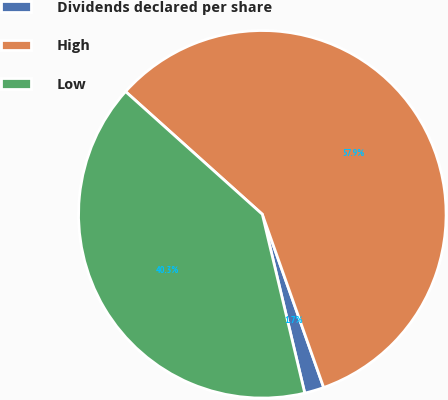Convert chart to OTSL. <chart><loc_0><loc_0><loc_500><loc_500><pie_chart><fcel>Dividends declared per share<fcel>High<fcel>Low<nl><fcel>1.71%<fcel>57.94%<fcel>40.35%<nl></chart> 